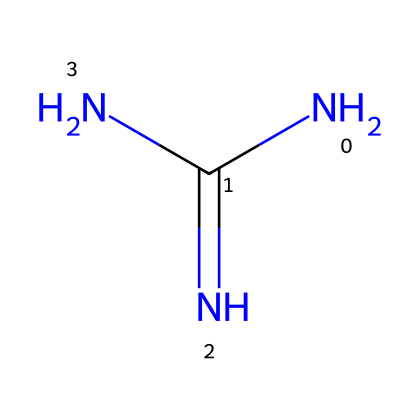What is the molecular formula of guanidine? The chemical structure has one carbon atom (C), four hydrogen atoms (H), and three nitrogen atoms (N), which can be counted directly from the structure. Combining these gives the molecular formula C1H4N3, often written as CH5N3.
Answer: CH5N3 How many nitrogen atoms are in guanidine? By examining the chemical structure, I can identify three distinct nitrogen atoms present, as indicated by the N symbols in the SMILES representation.
Answer: 3 What type of bonding is primarily present in guanidine? The chemical structure shows the presence of single bonds between all the atoms (C–N and N–H), indicating that guanidine consists mainly of covalent bonds.
Answer: covalent What functional groups are present in guanidine? The chemical structure contains a guanidine group, which features amino and imine functional characteristics, specifically highlighted by the presence of both nitrogen atoms bonded to carbon in a way that indicates basic properties.
Answer: guanidine group What property allows guanidine to act as a superbase? Guanidine contains multiple nitrogen atoms, which contribute to its ability to accept protons easily, thus making it a strong base compared to conventional bases. The electron-donating nature of nitrogen enhances its superbase properties.
Answer: strong base Why is guanidine commonly used in cosmetics? Guanidine's properties, such as its strong basicity and ability to act as a stabilizing agent, make it suitable for use in cosmetic formulations, promoting stability and effectiveness in various applications.
Answer: stabilizing agent What is the geometry around the central carbon atom in guanidine? The central carbon atom is connected to three nitrogen atoms, suggesting a trigonal planar geometry based on the structure, as the nitrogen atoms spread out to minimize electron repulsion.
Answer: trigonal planar 